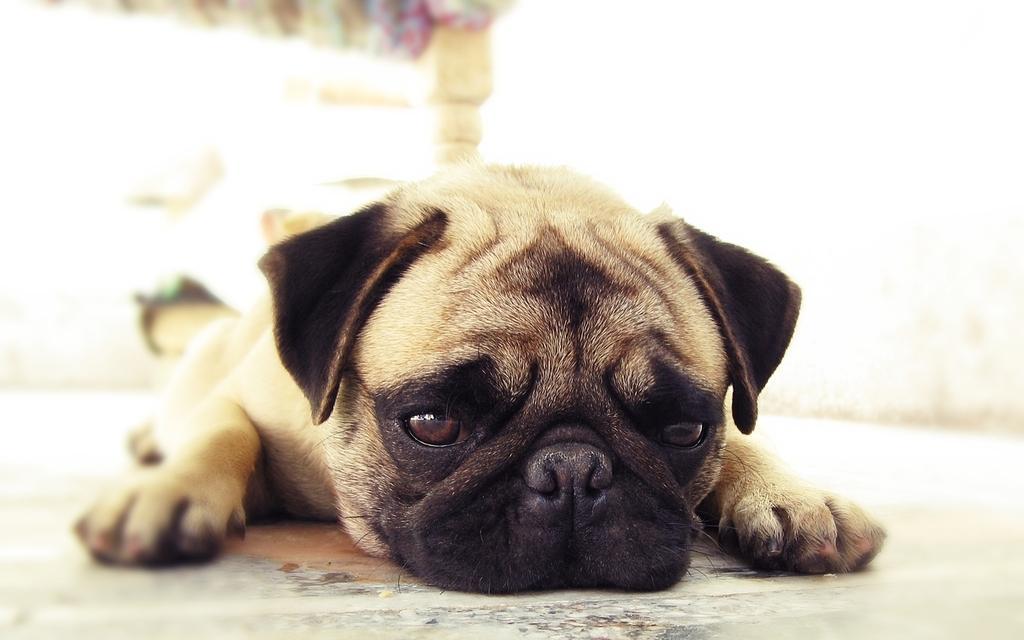Could you give a brief overview of what you see in this image? In this image, we can see a puppy lying on the surface and there is a blurred background. 